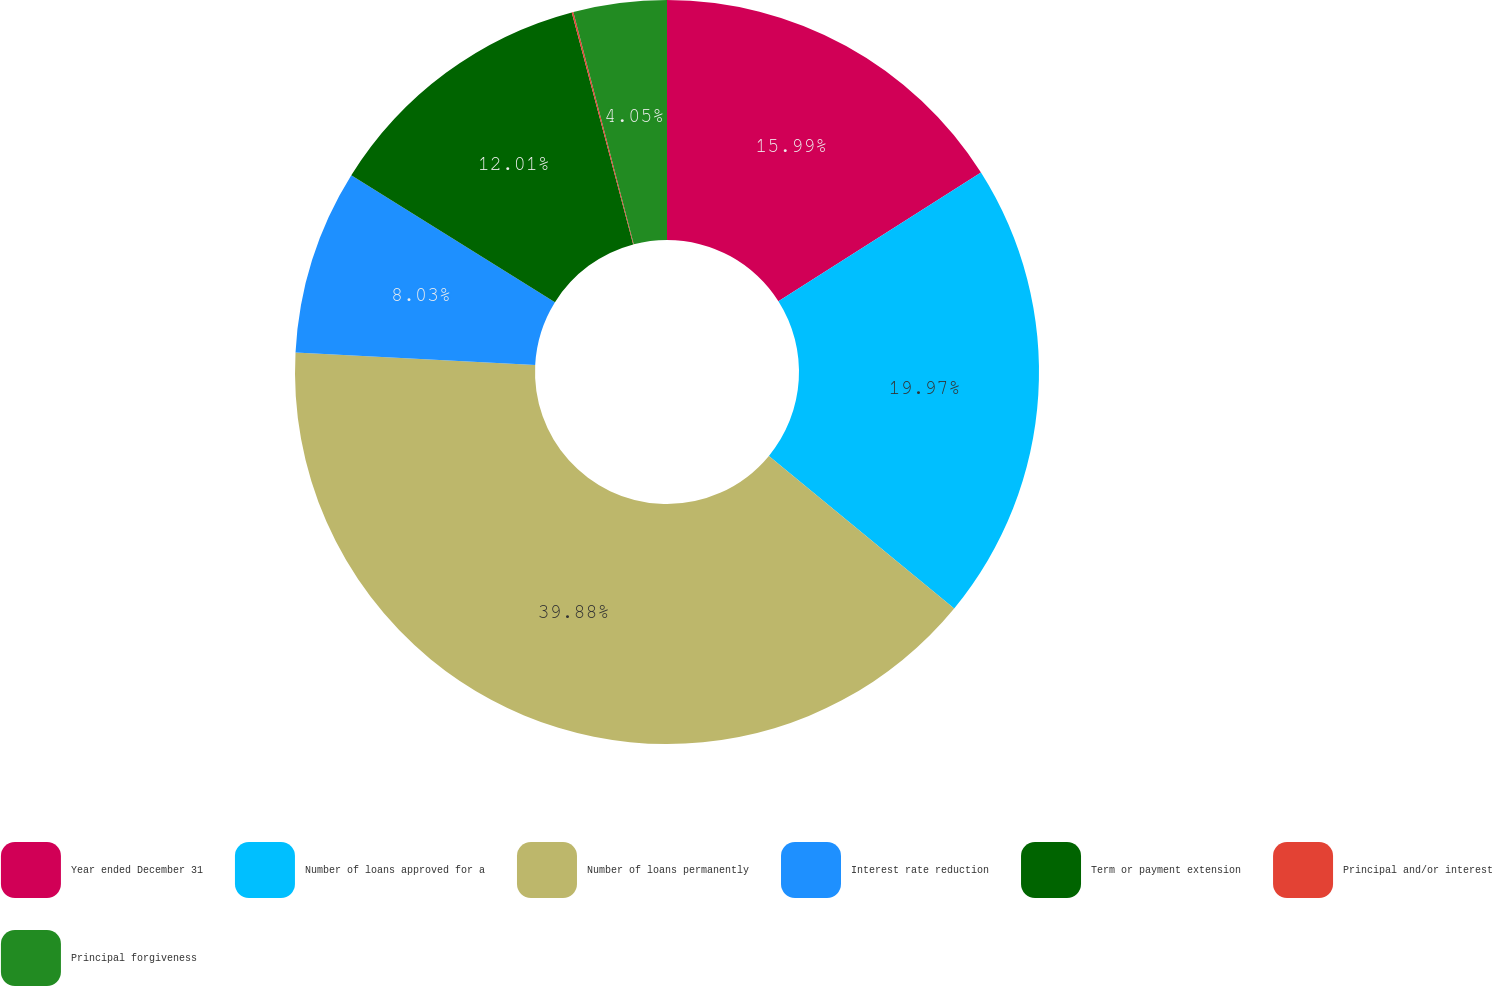Convert chart. <chart><loc_0><loc_0><loc_500><loc_500><pie_chart><fcel>Year ended December 31<fcel>Number of loans approved for a<fcel>Number of loans permanently<fcel>Interest rate reduction<fcel>Term or payment extension<fcel>Principal and/or interest<fcel>Principal forgiveness<nl><fcel>15.99%<fcel>19.97%<fcel>39.87%<fcel>8.03%<fcel>12.01%<fcel>0.07%<fcel>4.05%<nl></chart> 